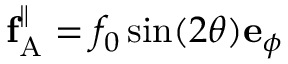<formula> <loc_0><loc_0><loc_500><loc_500>f _ { A } ^ { \| } = f _ { 0 } \sin ( 2 \theta ) e _ { \phi }</formula> 